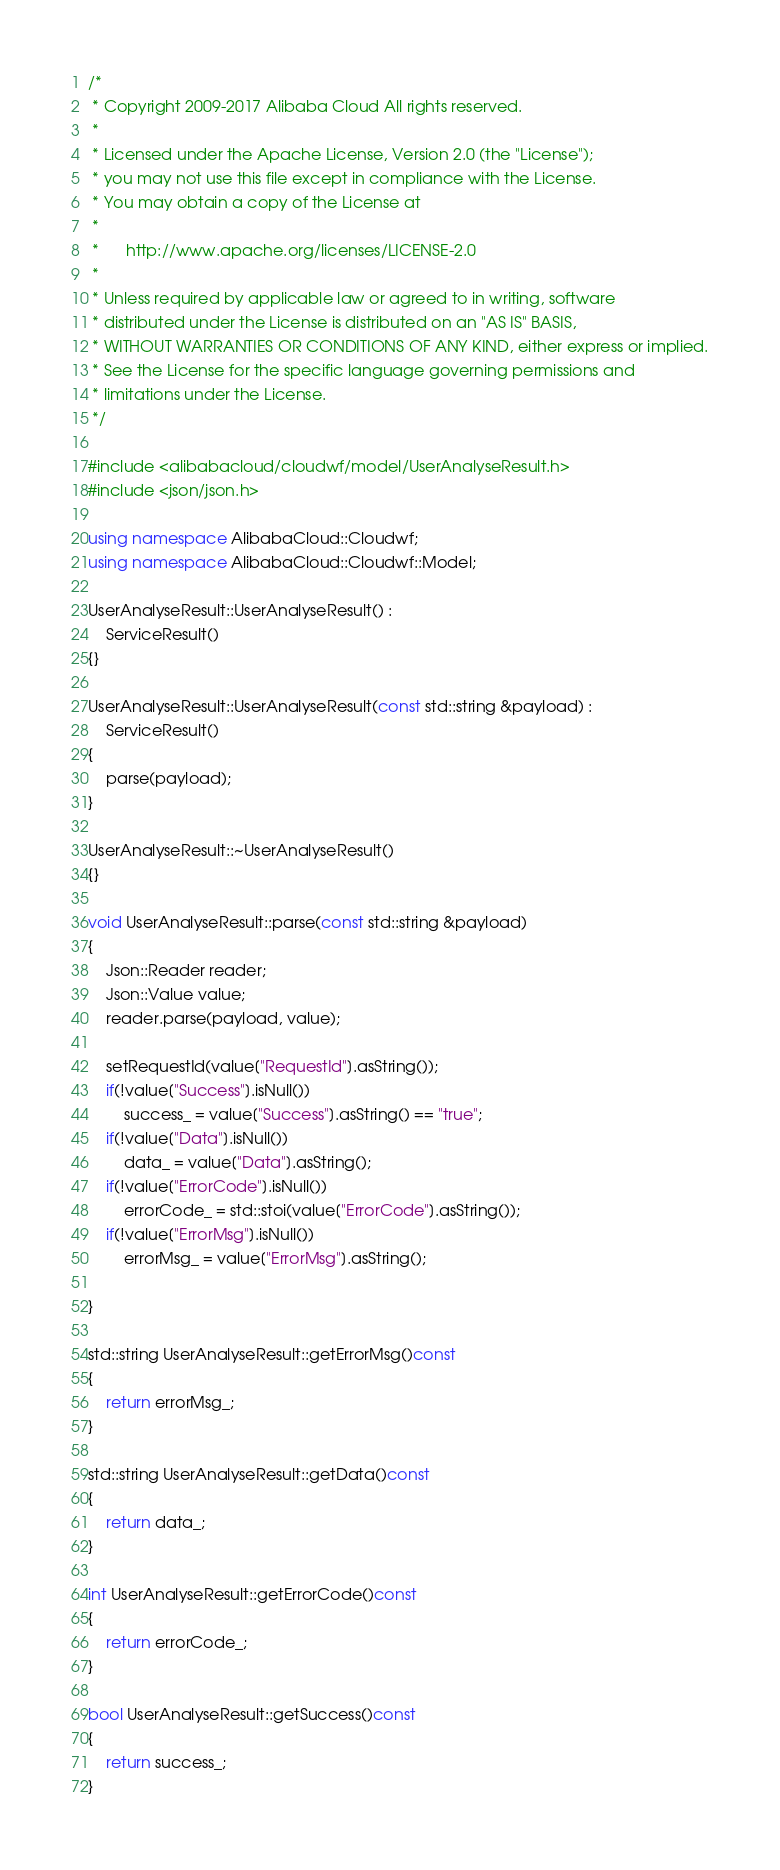Convert code to text. <code><loc_0><loc_0><loc_500><loc_500><_C++_>/*
 * Copyright 2009-2017 Alibaba Cloud All rights reserved.
 * 
 * Licensed under the Apache License, Version 2.0 (the "License");
 * you may not use this file except in compliance with the License.
 * You may obtain a copy of the License at
 * 
 *      http://www.apache.org/licenses/LICENSE-2.0
 * 
 * Unless required by applicable law or agreed to in writing, software
 * distributed under the License is distributed on an "AS IS" BASIS,
 * WITHOUT WARRANTIES OR CONDITIONS OF ANY KIND, either express or implied.
 * See the License for the specific language governing permissions and
 * limitations under the License.
 */

#include <alibabacloud/cloudwf/model/UserAnalyseResult.h>
#include <json/json.h>

using namespace AlibabaCloud::Cloudwf;
using namespace AlibabaCloud::Cloudwf::Model;

UserAnalyseResult::UserAnalyseResult() :
	ServiceResult()
{}

UserAnalyseResult::UserAnalyseResult(const std::string &payload) :
	ServiceResult()
{
	parse(payload);
}

UserAnalyseResult::~UserAnalyseResult()
{}

void UserAnalyseResult::parse(const std::string &payload)
{
	Json::Reader reader;
	Json::Value value;
	reader.parse(payload, value);

	setRequestId(value["RequestId"].asString());
	if(!value["Success"].isNull())
		success_ = value["Success"].asString() == "true";
	if(!value["Data"].isNull())
		data_ = value["Data"].asString();
	if(!value["ErrorCode"].isNull())
		errorCode_ = std::stoi(value["ErrorCode"].asString());
	if(!value["ErrorMsg"].isNull())
		errorMsg_ = value["ErrorMsg"].asString();

}

std::string UserAnalyseResult::getErrorMsg()const
{
	return errorMsg_;
}

std::string UserAnalyseResult::getData()const
{
	return data_;
}

int UserAnalyseResult::getErrorCode()const
{
	return errorCode_;
}

bool UserAnalyseResult::getSuccess()const
{
	return success_;
}

</code> 